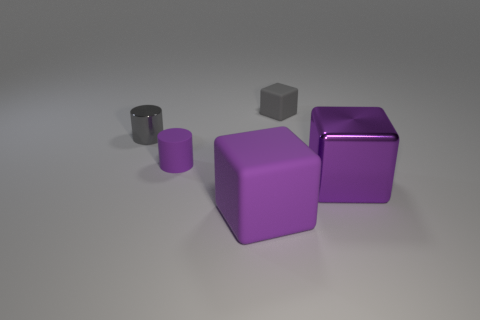Does the small purple thing have the same shape as the large purple rubber object?
Your answer should be very brief. No. Is there any other thing of the same color as the small metallic object?
Ensure brevity in your answer.  Yes. What is the color of the other big object that is the same shape as the large metal thing?
Give a very brief answer. Purple. Are there more purple objects that are to the left of the small gray cube than small gray matte cubes?
Your answer should be compact. Yes. There is a matte object that is on the right side of the large purple matte object; what color is it?
Give a very brief answer. Gray. Does the purple metallic block have the same size as the purple matte cube?
Offer a terse response. Yes. The purple cylinder has what size?
Keep it short and to the point. Small. What shape is the small matte thing that is the same color as the shiny block?
Ensure brevity in your answer.  Cylinder. Is the number of tiny blocks greater than the number of tiny objects?
Keep it short and to the point. No. What color is the matte thing that is to the right of the large cube in front of the big purple metallic cube in front of the small purple matte cylinder?
Give a very brief answer. Gray. 